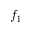Convert formula to latex. <formula><loc_0><loc_0><loc_500><loc_500>f _ { 1 }</formula> 